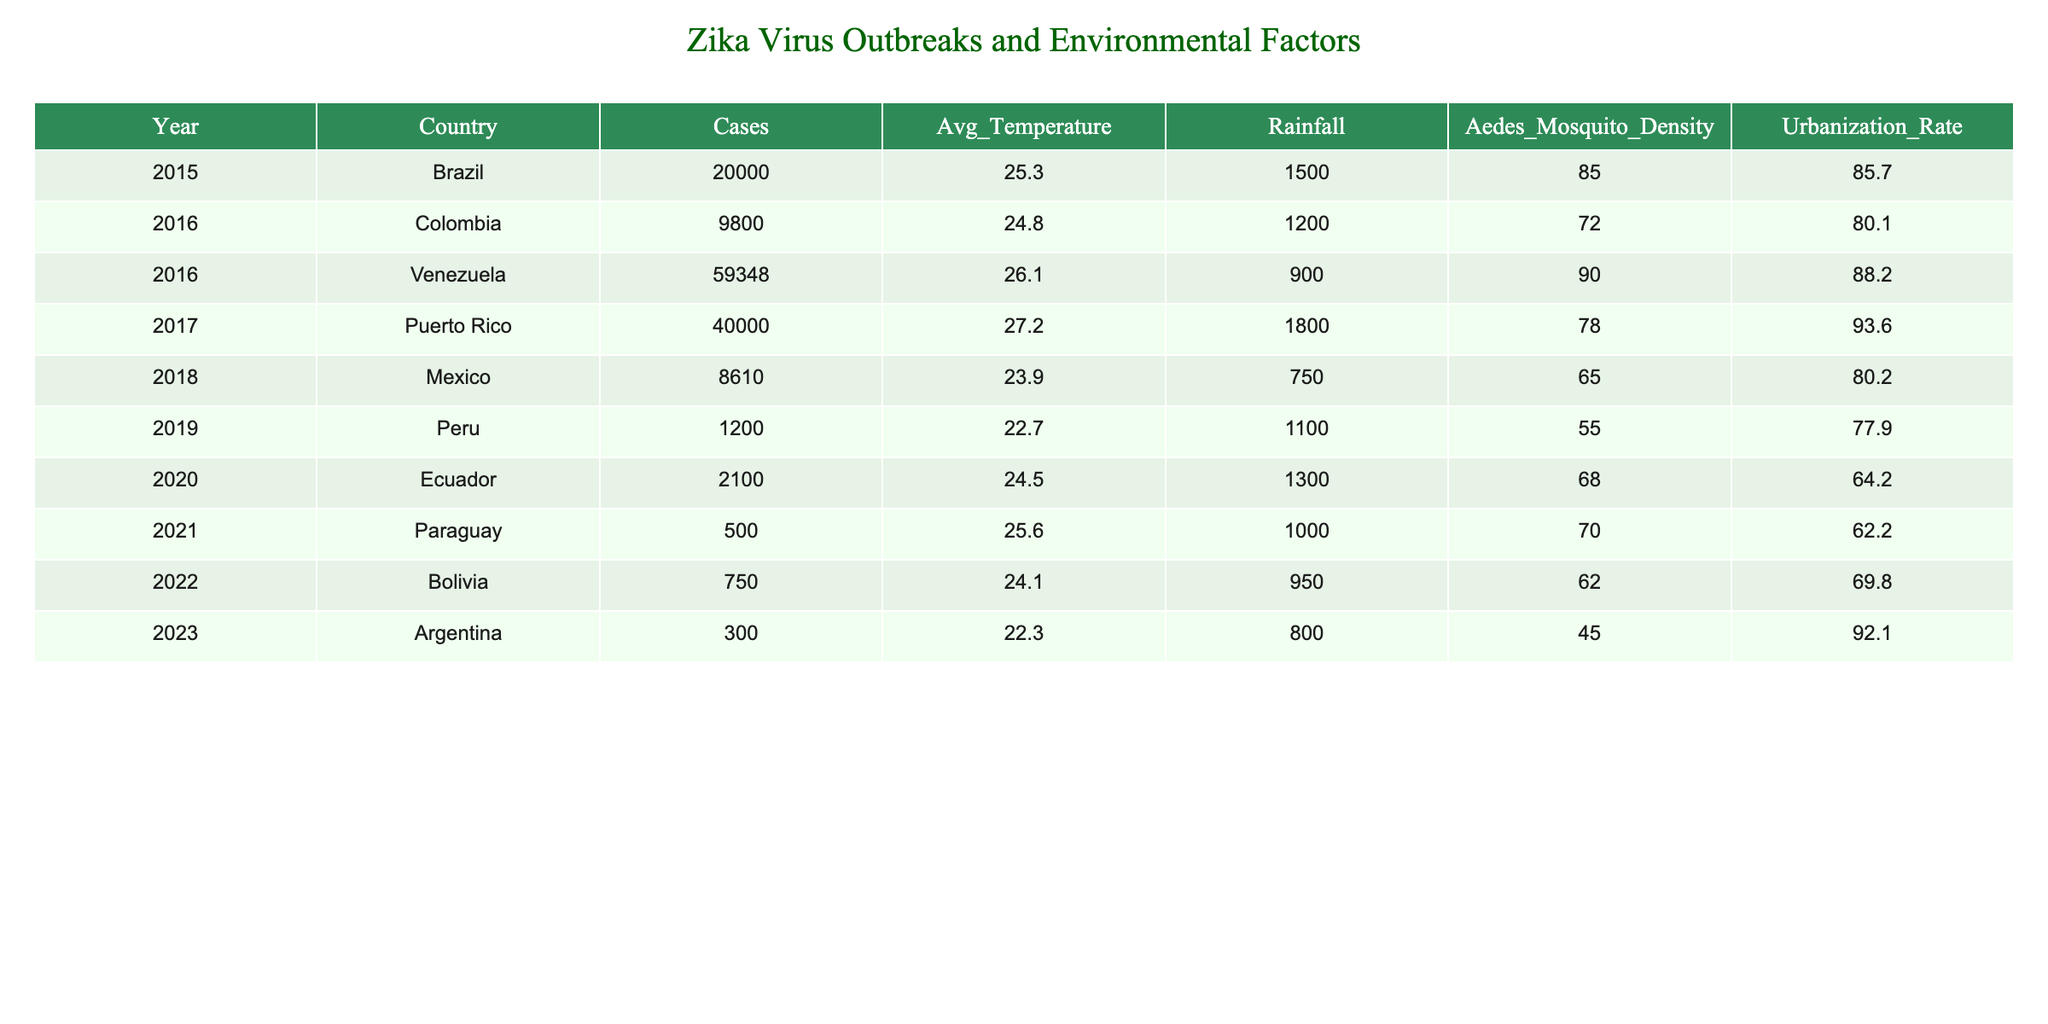What country reported the highest number of Zika virus cases in 2016? In 2016, Venezuela reported 59,348 cases, which is higher than Colombia's 9,800 cases.
Answer: Venezuela What was the average temperature during the Zika outbreaks in Brazil? In the table, Brazil's average temperature is listed as 25.3 degrees Celsius.
Answer: 25.3 °C Which year had the lowest Aedes mosquito density? Looking at the Aedes mosquito density column, Peru in 2019 had the lowest density at 55.
Answer: 55 What is the total number of Zika virus cases reported from 2015 to 2023? To find the total, sum the cases: 20000 + 9800 + 59348 + 40000 + 8610 + 1200 + 2100 + 500 + 750 + 300 = 102,608.
Answer: 102,608 Is there a correlation between urbanization rates and Zika virus cases? This requires analysis of the data from both columns. However, there's no direct answer without further statistical analysis; individual trends could be inferred but not conclusively stated as correlation.
Answer: No (based on table data alone) What was the average rainfall for the countries listed in the table? To find the average rainfall, sum all rainfall amounts: 1500 + 1200 + 900 + 1800 + 750 + 1100 + 1300 + 1000 + 950 + 800 = 10,300. Then divide by the number of years (10): 10,300 / 10 = 1,030.
Answer: 1,030 mm In which country did the highest urbanization rate occur during the reported years? By reviewing the 'Urbanization Rate' column, Venezuela in 2016 showed the highest urbanization rate at 88.2%.
Answer: Venezuela Was there an increase in Zika cases from 2015 to 2016? Yes, comparing the cases in Brazil (20,000) in 2015 to 98,000 total cases in Colombia and Venezuela in 2016, the number increased.
Answer: Yes Does the data show that rainfall impacts the number of Zika cases in a straightforward manner? While higher rainfall was recorded in Puerto Rico in 2017 (1800) with significant cases (40,000), it does not establish a clear cause-effect relation without deeper analysis.
Answer: No (requires more analysis) What country shows the trend of decreasing cases from 2016 onwards? By looking at the cases for each year, Colombia and Brazil reported a decrease compared to the massive outbreak years. However, the data suggests only Ecuador had a significant drop after 2017.
Answer: Ecuador 